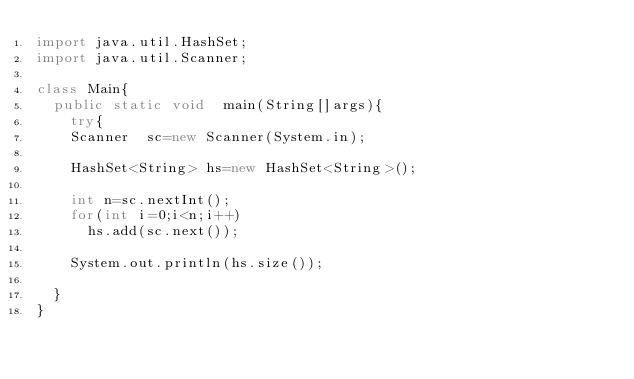<code> <loc_0><loc_0><loc_500><loc_500><_Java_>import java.util.HashSet;
import java.util.Scanner;

class Main{
  public static void  main(String[]args){
    try{
    Scanner  sc=new Scanner(System.in);
    
    HashSet<String> hs=new HashSet<String>();
    
    int n=sc.nextInt();
    for(int i=0;i<n;i++)
      hs.add(sc.next());
    
    System.out.println(hs.size());
      
  }
}

</code> 